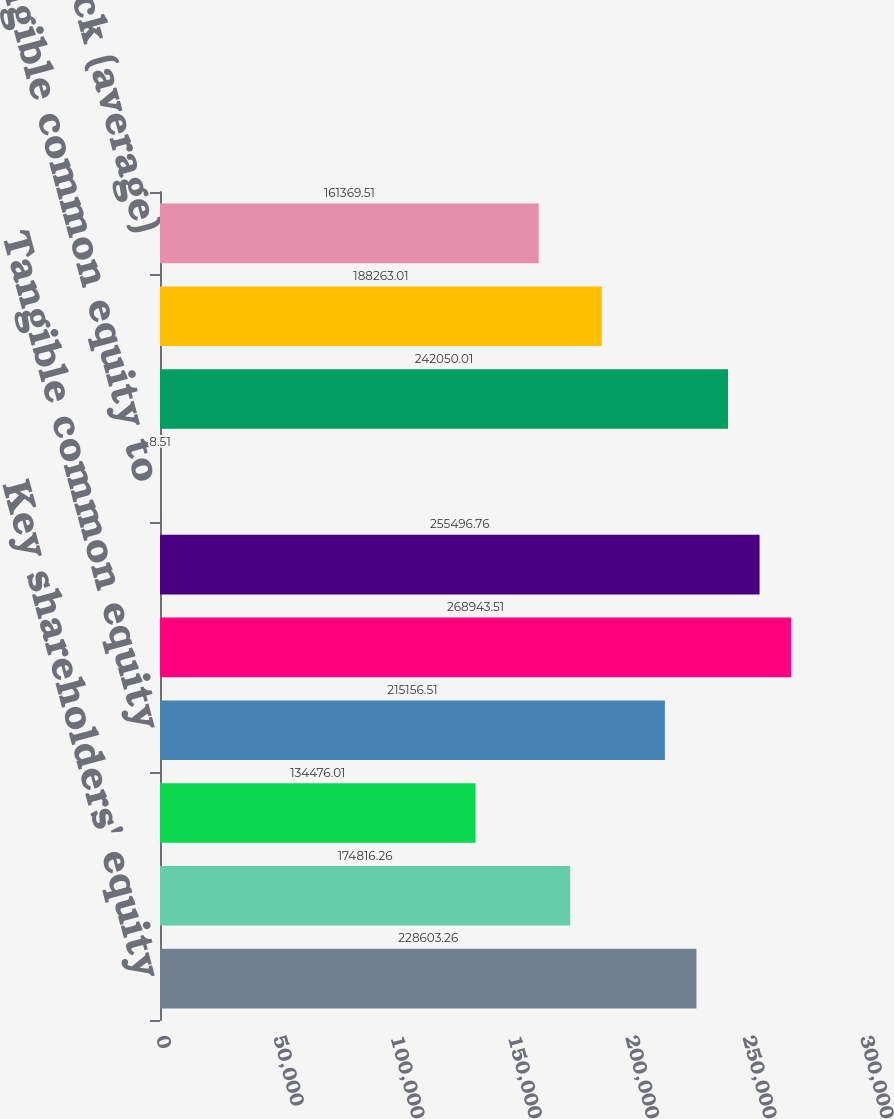Convert chart. <chart><loc_0><loc_0><loc_500><loc_500><bar_chart><fcel>Key shareholders' equity<fcel>Less Intangible assets (a)<fcel>Preferred Stock (b)<fcel>Tangible common equity<fcel>Total assets (GAAP)<fcel>Tangible assets (non-GAAP)<fcel>Tangible common equity to<fcel>Average Key shareholders'<fcel>Less Intangible assets<fcel>Preferred Stock (average)<nl><fcel>228603<fcel>174816<fcel>134476<fcel>215157<fcel>268944<fcel>255497<fcel>8.51<fcel>242050<fcel>188263<fcel>161370<nl></chart> 